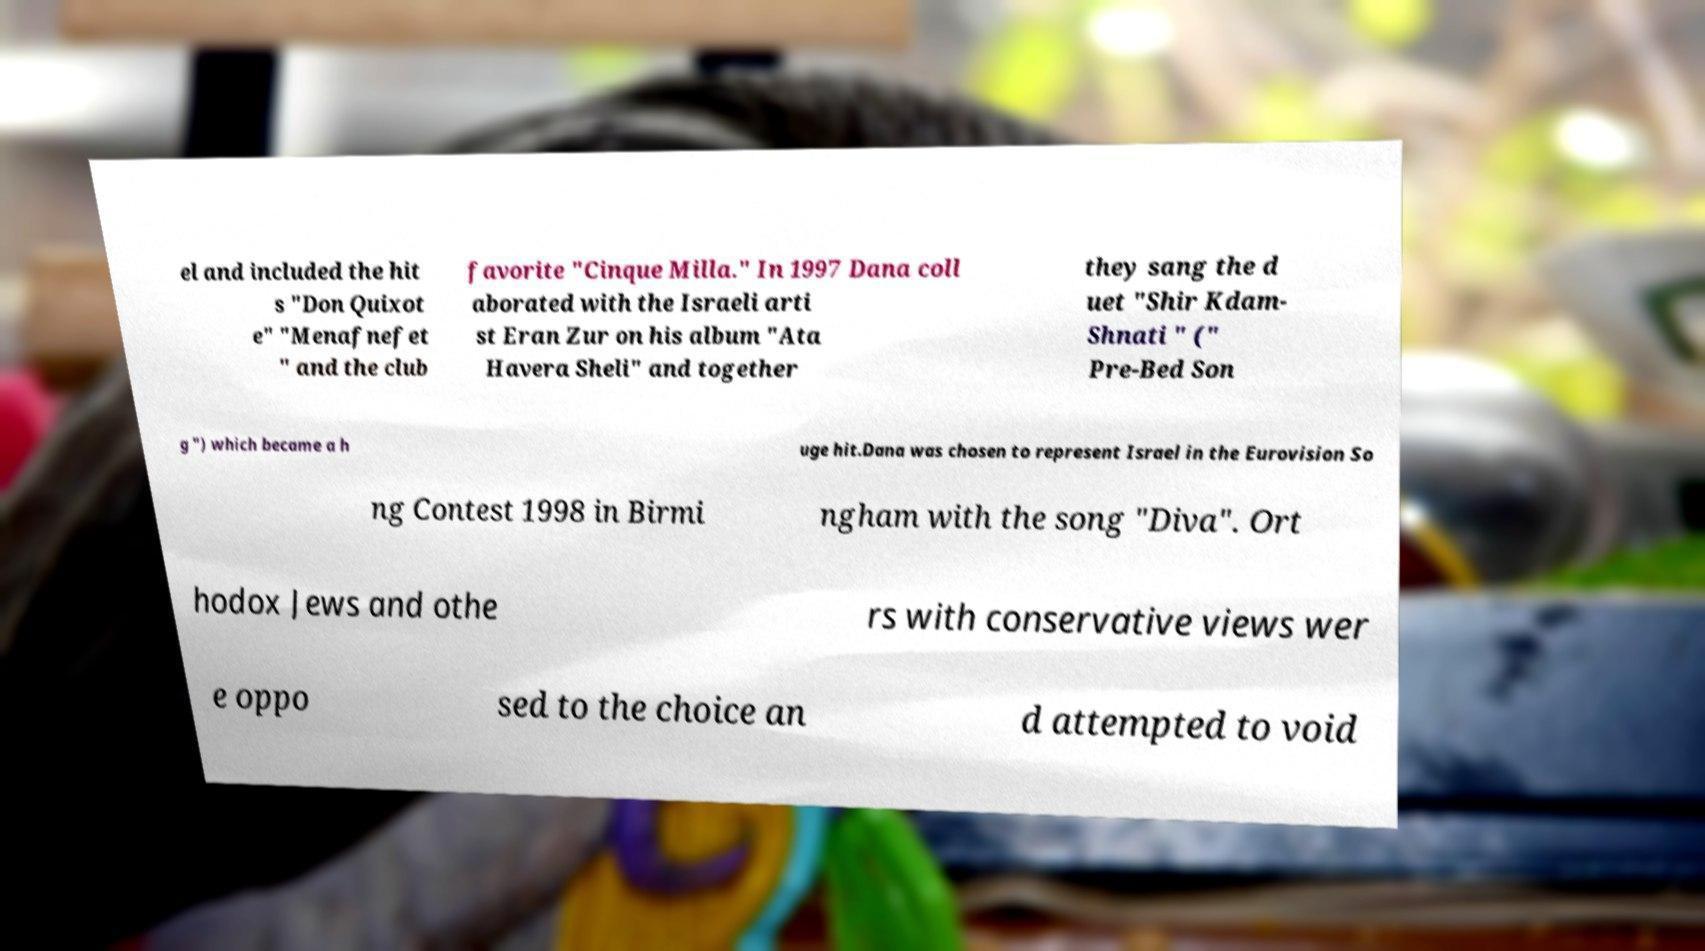What messages or text are displayed in this image? I need them in a readable, typed format. el and included the hit s "Don Quixot e" "Menafnefet " and the club favorite "Cinque Milla." In 1997 Dana coll aborated with the Israeli arti st Eran Zur on his album "Ata Havera Sheli" and together they sang the d uet "Shir Kdam- Shnati " (" Pre-Bed Son g ") which became a h uge hit.Dana was chosen to represent Israel in the Eurovision So ng Contest 1998 in Birmi ngham with the song "Diva". Ort hodox Jews and othe rs with conservative views wer e oppo sed to the choice an d attempted to void 